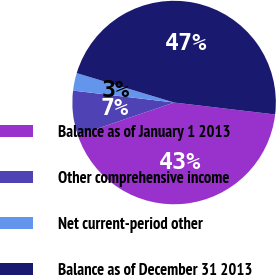Convert chart to OTSL. <chart><loc_0><loc_0><loc_500><loc_500><pie_chart><fcel>Balance as of January 1 2013<fcel>Other comprehensive income<fcel>Net current-period other<fcel>Balance as of December 31 2013<nl><fcel>42.91%<fcel>7.09%<fcel>2.8%<fcel>47.2%<nl></chart> 